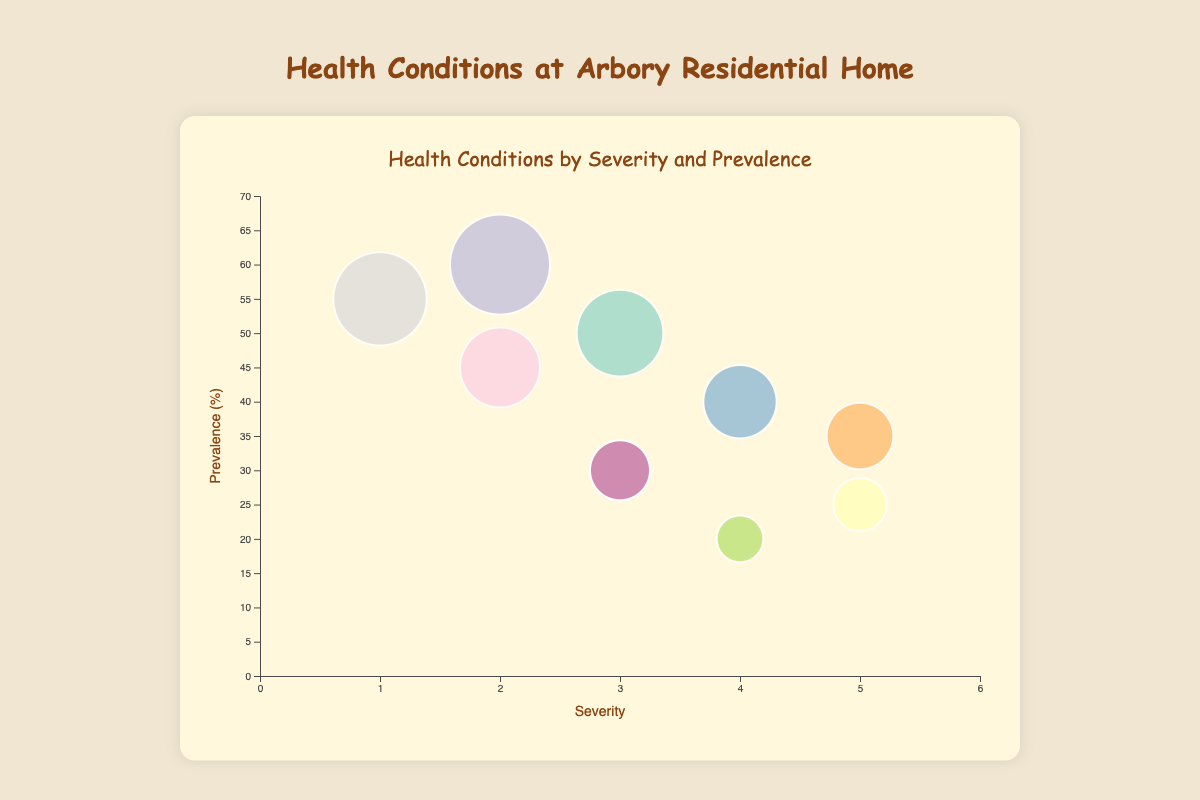What's the title of the chart? The chart title is located at the top and usually provides a summary of what the chart is about. In this case, it reads "Health Conditions by Severity and Prevalence".
Answer: Health Conditions by Severity and Prevalence How many health conditions are displayed in the chart? By counting the number of bubbles or data points present in the chart, you can determine the number of health conditions. There are ten bubbles in the chart.
Answer: 10 Which health condition has the highest prevalence? Prevalence is shown on the vertical axis. The bubble with the highest vertical position represents the highest prevalence. "Hypertension" has the highest prevalence at 60%.
Answer: Hypertension Which condition is the most severe? Severity is indicated on the horizontal axis. The bubble furthest to the right represents the highest severity. Both "Alzheimer's Disease" and "Cardiovascular Diseases" have a severity of 5.
Answer: Alzheimer's Disease and Cardiovascular Diseases Which health condition has the largest bubble size? The size of the bubble represents the prevalence of the condition. The largest bubble on the chart corresponds to "Hypertension".
Answer: Hypertension Which conditions have a prevalence between 30% and 50%? Prevalence values can be found by looking at the vertical positions of the bubbles. The conditions that fall within the given range are "Arthritis", "Osteoporosis", "Visual Impairment", and "Hearing Loss".
Answer: Arthritis, Osteoporosis, Visual Impairment, Hearing Loss What's the severity of the condition with the lowest prevalence? The condition with the lowest prevalence is "Chronic Obstructive Pulmonary Disease (COPD)" at 20%. The severity of this condition, which is shown horizontally, is 4.
Answer: 4 Which condition has a higher prevalence, Diabetes or Depression? By comparing the vertical positions of the bubbles for "Diabetes" and "Depression", we can see that both have the same prevalence, which is 30%.
Answer: Same prevalence (30%) How many conditions have a severity of 3? Looking at the bubbles that align with a severity of 3 on the horizontal axis, we find three conditions: "Arthritis", "Diabetes", and "Depression".
Answer: 3 conditions Is there any condition that has both a high severity (≥4) and a low prevalence (≤25%)? Checking the bubbles that are to the right (high severity) and towards the bottom (low prevalence), we find "Alzheimer's Disease" and "Chronic Obstructive Pulmonary Disease (COPD)" fit the criteria.
Answer: Alzheimer's Disease and Chronic Obstructive Pulmonary Disease (COPD) 